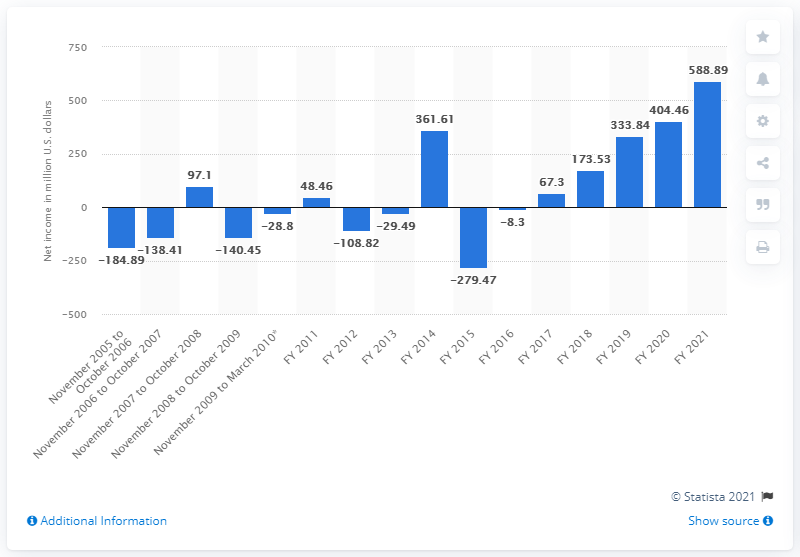How does the net income for 2021 compare to earlier years? The net income for 2021, shown as $588.89 million, is the highest recorded over the period displayed in the image. It shows a significant recovery and growth compared to previous years, especially noting the substantial increase from the $404.46 million in 2020. 